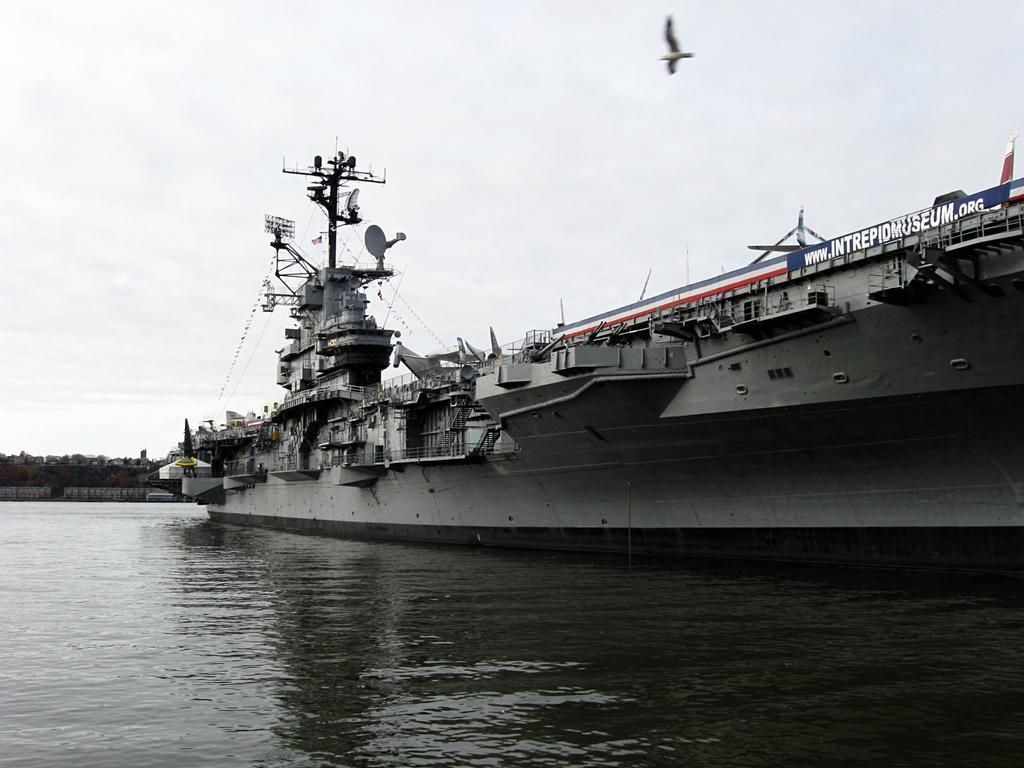Describe this image in one or two sentences. In this image, there is water and there is a ship, at the top there is a bird flying and there is a white color sky. 